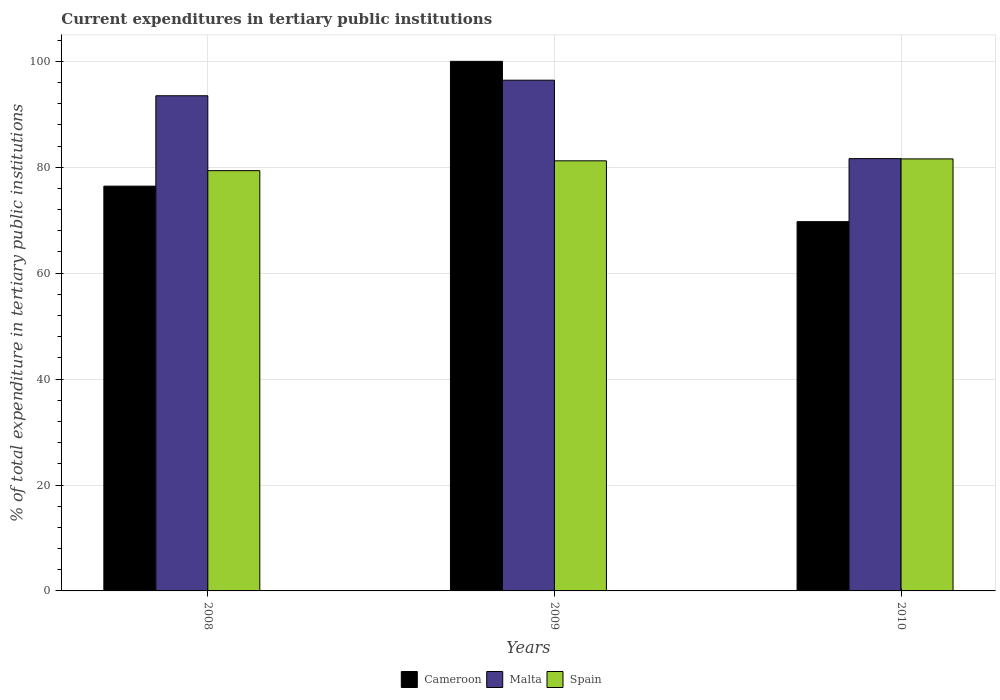How many different coloured bars are there?
Keep it short and to the point. 3. Are the number of bars per tick equal to the number of legend labels?
Your response must be concise. Yes. How many bars are there on the 3rd tick from the right?
Ensure brevity in your answer.  3. What is the label of the 2nd group of bars from the left?
Keep it short and to the point. 2009. What is the current expenditures in tertiary public institutions in Cameroon in 2009?
Offer a very short reply. 100. Across all years, what is the maximum current expenditures in tertiary public institutions in Cameroon?
Keep it short and to the point. 100. Across all years, what is the minimum current expenditures in tertiary public institutions in Spain?
Provide a succinct answer. 79.36. What is the total current expenditures in tertiary public institutions in Malta in the graph?
Provide a short and direct response. 271.58. What is the difference between the current expenditures in tertiary public institutions in Spain in 2008 and that in 2009?
Provide a succinct answer. -1.86. What is the difference between the current expenditures in tertiary public institutions in Spain in 2010 and the current expenditures in tertiary public institutions in Malta in 2009?
Your response must be concise. -14.86. What is the average current expenditures in tertiary public institutions in Cameroon per year?
Your answer should be compact. 82.05. In the year 2008, what is the difference between the current expenditures in tertiary public institutions in Cameroon and current expenditures in tertiary public institutions in Malta?
Your response must be concise. -17.07. In how many years, is the current expenditures in tertiary public institutions in Malta greater than 68 %?
Make the answer very short. 3. What is the ratio of the current expenditures in tertiary public institutions in Spain in 2009 to that in 2010?
Make the answer very short. 1. Is the difference between the current expenditures in tertiary public institutions in Cameroon in 2008 and 2009 greater than the difference between the current expenditures in tertiary public institutions in Malta in 2008 and 2009?
Your answer should be very brief. No. What is the difference between the highest and the second highest current expenditures in tertiary public institutions in Cameroon?
Keep it short and to the point. 23.57. What is the difference between the highest and the lowest current expenditures in tertiary public institutions in Cameroon?
Offer a terse response. 30.27. In how many years, is the current expenditures in tertiary public institutions in Malta greater than the average current expenditures in tertiary public institutions in Malta taken over all years?
Make the answer very short. 2. Is the sum of the current expenditures in tertiary public institutions in Spain in 2008 and 2009 greater than the maximum current expenditures in tertiary public institutions in Cameroon across all years?
Provide a succinct answer. Yes. What does the 1st bar from the left in 2009 represents?
Give a very brief answer. Cameroon. What does the 2nd bar from the right in 2010 represents?
Make the answer very short. Malta. Are all the bars in the graph horizontal?
Provide a short and direct response. No. How many years are there in the graph?
Give a very brief answer. 3. What is the difference between two consecutive major ticks on the Y-axis?
Your response must be concise. 20. Does the graph contain grids?
Give a very brief answer. Yes. Where does the legend appear in the graph?
Your answer should be compact. Bottom center. What is the title of the graph?
Provide a succinct answer. Current expenditures in tertiary public institutions. What is the label or title of the X-axis?
Provide a short and direct response. Years. What is the label or title of the Y-axis?
Ensure brevity in your answer.  % of total expenditure in tertiary public institutions. What is the % of total expenditure in tertiary public institutions of Cameroon in 2008?
Your answer should be compact. 76.43. What is the % of total expenditure in tertiary public institutions in Malta in 2008?
Keep it short and to the point. 93.5. What is the % of total expenditure in tertiary public institutions in Spain in 2008?
Your answer should be compact. 79.36. What is the % of total expenditure in tertiary public institutions in Malta in 2009?
Provide a succinct answer. 96.44. What is the % of total expenditure in tertiary public institutions of Spain in 2009?
Keep it short and to the point. 81.22. What is the % of total expenditure in tertiary public institutions of Cameroon in 2010?
Make the answer very short. 69.73. What is the % of total expenditure in tertiary public institutions in Malta in 2010?
Provide a succinct answer. 81.63. What is the % of total expenditure in tertiary public institutions of Spain in 2010?
Your answer should be compact. 81.58. Across all years, what is the maximum % of total expenditure in tertiary public institutions in Malta?
Make the answer very short. 96.44. Across all years, what is the maximum % of total expenditure in tertiary public institutions in Spain?
Provide a short and direct response. 81.58. Across all years, what is the minimum % of total expenditure in tertiary public institutions of Cameroon?
Offer a terse response. 69.73. Across all years, what is the minimum % of total expenditure in tertiary public institutions in Malta?
Give a very brief answer. 81.63. Across all years, what is the minimum % of total expenditure in tertiary public institutions in Spain?
Your answer should be very brief. 79.36. What is the total % of total expenditure in tertiary public institutions of Cameroon in the graph?
Your response must be concise. 246.16. What is the total % of total expenditure in tertiary public institutions of Malta in the graph?
Keep it short and to the point. 271.58. What is the total % of total expenditure in tertiary public institutions in Spain in the graph?
Provide a short and direct response. 242.16. What is the difference between the % of total expenditure in tertiary public institutions in Cameroon in 2008 and that in 2009?
Keep it short and to the point. -23.57. What is the difference between the % of total expenditure in tertiary public institutions in Malta in 2008 and that in 2009?
Provide a succinct answer. -2.94. What is the difference between the % of total expenditure in tertiary public institutions of Spain in 2008 and that in 2009?
Your answer should be very brief. -1.86. What is the difference between the % of total expenditure in tertiary public institutions in Cameroon in 2008 and that in 2010?
Provide a succinct answer. 6.7. What is the difference between the % of total expenditure in tertiary public institutions of Malta in 2008 and that in 2010?
Provide a succinct answer. 11.87. What is the difference between the % of total expenditure in tertiary public institutions of Spain in 2008 and that in 2010?
Keep it short and to the point. -2.22. What is the difference between the % of total expenditure in tertiary public institutions in Cameroon in 2009 and that in 2010?
Your answer should be very brief. 30.27. What is the difference between the % of total expenditure in tertiary public institutions of Malta in 2009 and that in 2010?
Your answer should be very brief. 14.81. What is the difference between the % of total expenditure in tertiary public institutions of Spain in 2009 and that in 2010?
Provide a short and direct response. -0.36. What is the difference between the % of total expenditure in tertiary public institutions of Cameroon in 2008 and the % of total expenditure in tertiary public institutions of Malta in 2009?
Your answer should be compact. -20.01. What is the difference between the % of total expenditure in tertiary public institutions of Cameroon in 2008 and the % of total expenditure in tertiary public institutions of Spain in 2009?
Provide a succinct answer. -4.78. What is the difference between the % of total expenditure in tertiary public institutions of Malta in 2008 and the % of total expenditure in tertiary public institutions of Spain in 2009?
Give a very brief answer. 12.29. What is the difference between the % of total expenditure in tertiary public institutions in Cameroon in 2008 and the % of total expenditure in tertiary public institutions in Malta in 2010?
Keep it short and to the point. -5.2. What is the difference between the % of total expenditure in tertiary public institutions of Cameroon in 2008 and the % of total expenditure in tertiary public institutions of Spain in 2010?
Ensure brevity in your answer.  -5.15. What is the difference between the % of total expenditure in tertiary public institutions in Malta in 2008 and the % of total expenditure in tertiary public institutions in Spain in 2010?
Your answer should be compact. 11.92. What is the difference between the % of total expenditure in tertiary public institutions of Cameroon in 2009 and the % of total expenditure in tertiary public institutions of Malta in 2010?
Your answer should be very brief. 18.37. What is the difference between the % of total expenditure in tertiary public institutions in Cameroon in 2009 and the % of total expenditure in tertiary public institutions in Spain in 2010?
Your answer should be very brief. 18.42. What is the difference between the % of total expenditure in tertiary public institutions of Malta in 2009 and the % of total expenditure in tertiary public institutions of Spain in 2010?
Your answer should be very brief. 14.86. What is the average % of total expenditure in tertiary public institutions in Cameroon per year?
Offer a terse response. 82.05. What is the average % of total expenditure in tertiary public institutions in Malta per year?
Your answer should be very brief. 90.53. What is the average % of total expenditure in tertiary public institutions in Spain per year?
Offer a very short reply. 80.72. In the year 2008, what is the difference between the % of total expenditure in tertiary public institutions of Cameroon and % of total expenditure in tertiary public institutions of Malta?
Keep it short and to the point. -17.07. In the year 2008, what is the difference between the % of total expenditure in tertiary public institutions of Cameroon and % of total expenditure in tertiary public institutions of Spain?
Offer a terse response. -2.92. In the year 2008, what is the difference between the % of total expenditure in tertiary public institutions of Malta and % of total expenditure in tertiary public institutions of Spain?
Provide a succinct answer. 14.15. In the year 2009, what is the difference between the % of total expenditure in tertiary public institutions in Cameroon and % of total expenditure in tertiary public institutions in Malta?
Ensure brevity in your answer.  3.56. In the year 2009, what is the difference between the % of total expenditure in tertiary public institutions in Cameroon and % of total expenditure in tertiary public institutions in Spain?
Make the answer very short. 18.78. In the year 2009, what is the difference between the % of total expenditure in tertiary public institutions of Malta and % of total expenditure in tertiary public institutions of Spain?
Your answer should be compact. 15.22. In the year 2010, what is the difference between the % of total expenditure in tertiary public institutions in Cameroon and % of total expenditure in tertiary public institutions in Malta?
Your answer should be very brief. -11.9. In the year 2010, what is the difference between the % of total expenditure in tertiary public institutions of Cameroon and % of total expenditure in tertiary public institutions of Spain?
Your response must be concise. -11.85. In the year 2010, what is the difference between the % of total expenditure in tertiary public institutions in Malta and % of total expenditure in tertiary public institutions in Spain?
Your answer should be very brief. 0.05. What is the ratio of the % of total expenditure in tertiary public institutions of Cameroon in 2008 to that in 2009?
Provide a short and direct response. 0.76. What is the ratio of the % of total expenditure in tertiary public institutions of Malta in 2008 to that in 2009?
Provide a succinct answer. 0.97. What is the ratio of the % of total expenditure in tertiary public institutions of Spain in 2008 to that in 2009?
Provide a short and direct response. 0.98. What is the ratio of the % of total expenditure in tertiary public institutions of Cameroon in 2008 to that in 2010?
Your answer should be very brief. 1.1. What is the ratio of the % of total expenditure in tertiary public institutions in Malta in 2008 to that in 2010?
Provide a succinct answer. 1.15. What is the ratio of the % of total expenditure in tertiary public institutions of Spain in 2008 to that in 2010?
Provide a succinct answer. 0.97. What is the ratio of the % of total expenditure in tertiary public institutions in Cameroon in 2009 to that in 2010?
Make the answer very short. 1.43. What is the ratio of the % of total expenditure in tertiary public institutions in Malta in 2009 to that in 2010?
Provide a succinct answer. 1.18. What is the difference between the highest and the second highest % of total expenditure in tertiary public institutions in Cameroon?
Keep it short and to the point. 23.57. What is the difference between the highest and the second highest % of total expenditure in tertiary public institutions of Malta?
Your answer should be compact. 2.94. What is the difference between the highest and the second highest % of total expenditure in tertiary public institutions in Spain?
Ensure brevity in your answer.  0.36. What is the difference between the highest and the lowest % of total expenditure in tertiary public institutions of Cameroon?
Make the answer very short. 30.27. What is the difference between the highest and the lowest % of total expenditure in tertiary public institutions in Malta?
Make the answer very short. 14.81. What is the difference between the highest and the lowest % of total expenditure in tertiary public institutions of Spain?
Give a very brief answer. 2.22. 